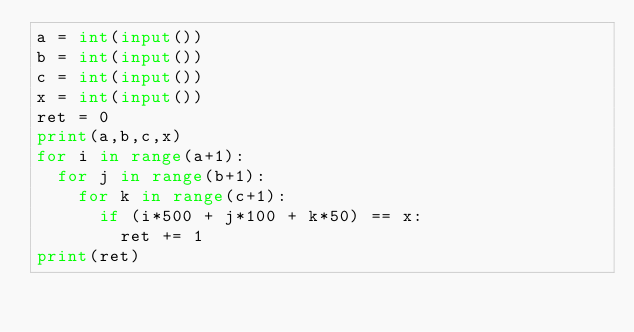<code> <loc_0><loc_0><loc_500><loc_500><_Python_>a = int(input())
b = int(input())
c = int(input())
x = int(input())
ret = 0
print(a,b,c,x)
for i in range(a+1):
  for j in range(b+1):
    for k in range(c+1):
      if (i*500 + j*100 + k*50) == x:
        ret += 1
print(ret)</code> 